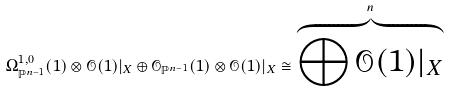<formula> <loc_0><loc_0><loc_500><loc_500>\Omega ^ { 1 , 0 } _ { \mathbb { P } ^ { n - 1 } } ( 1 ) \otimes \mathcal { O } ( 1 ) | _ { X } \oplus \mathcal { O } _ { \mathbb { P } ^ { n - 1 } } ( 1 ) \otimes \mathcal { O } ( 1 ) | _ { X } \cong \overbrace { \bigoplus \mathcal { O } ( 1 ) | _ { X } } ^ { n }</formula> 